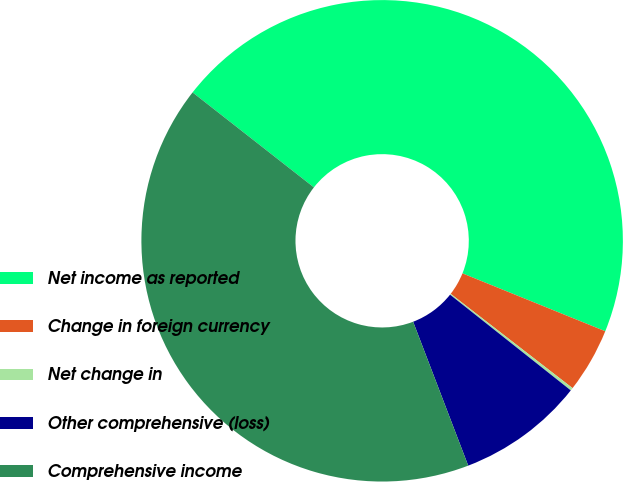Convert chart to OTSL. <chart><loc_0><loc_0><loc_500><loc_500><pie_chart><fcel>Net income as reported<fcel>Change in foreign currency<fcel>Net change in<fcel>Other comprehensive (loss)<fcel>Comprehensive income<nl><fcel>45.56%<fcel>4.35%<fcel>0.19%<fcel>8.51%<fcel>41.39%<nl></chart> 